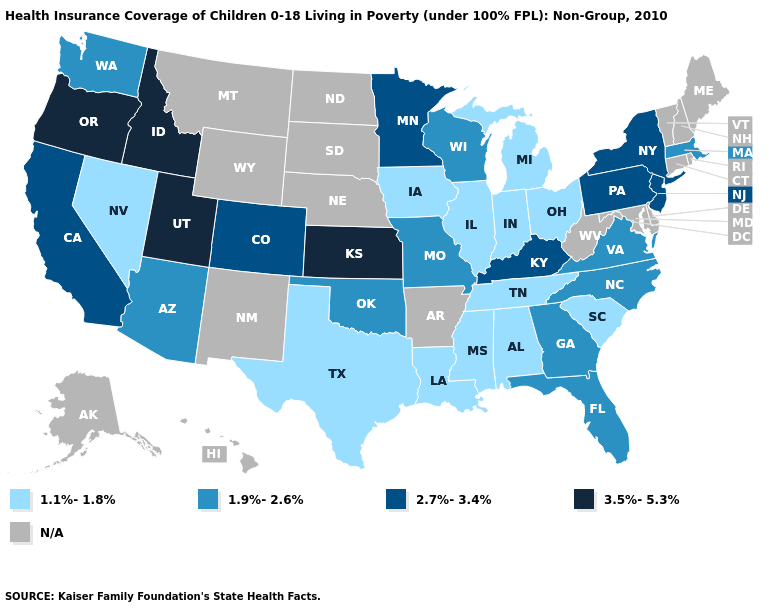Is the legend a continuous bar?
Give a very brief answer. No. What is the value of Delaware?
Write a very short answer. N/A. Name the states that have a value in the range N/A?
Keep it brief. Alaska, Arkansas, Connecticut, Delaware, Hawaii, Maine, Maryland, Montana, Nebraska, New Hampshire, New Mexico, North Dakota, Rhode Island, South Dakota, Vermont, West Virginia, Wyoming. What is the highest value in the South ?
Quick response, please. 2.7%-3.4%. Name the states that have a value in the range 2.7%-3.4%?
Concise answer only. California, Colorado, Kentucky, Minnesota, New Jersey, New York, Pennsylvania. Name the states that have a value in the range N/A?
Concise answer only. Alaska, Arkansas, Connecticut, Delaware, Hawaii, Maine, Maryland, Montana, Nebraska, New Hampshire, New Mexico, North Dakota, Rhode Island, South Dakota, Vermont, West Virginia, Wyoming. What is the highest value in states that border Mississippi?
Quick response, please. 1.1%-1.8%. Name the states that have a value in the range 3.5%-5.3%?
Write a very short answer. Idaho, Kansas, Oregon, Utah. Name the states that have a value in the range 1.9%-2.6%?
Write a very short answer. Arizona, Florida, Georgia, Massachusetts, Missouri, North Carolina, Oklahoma, Virginia, Washington, Wisconsin. Does the map have missing data?
Short answer required. Yes. Which states have the lowest value in the USA?
Be succinct. Alabama, Illinois, Indiana, Iowa, Louisiana, Michigan, Mississippi, Nevada, Ohio, South Carolina, Tennessee, Texas. Does the first symbol in the legend represent the smallest category?
Quick response, please. Yes. Is the legend a continuous bar?
Answer briefly. No. What is the lowest value in the MidWest?
Short answer required. 1.1%-1.8%. 